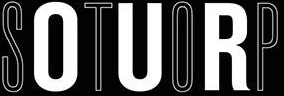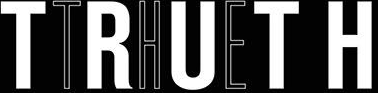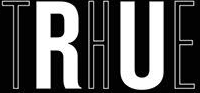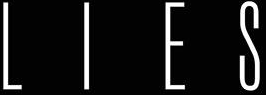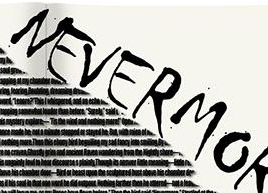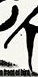Identify the words shown in these images in order, separated by a semicolon. STOP; TRUTH; THE; LIES; NEVERMO; # 